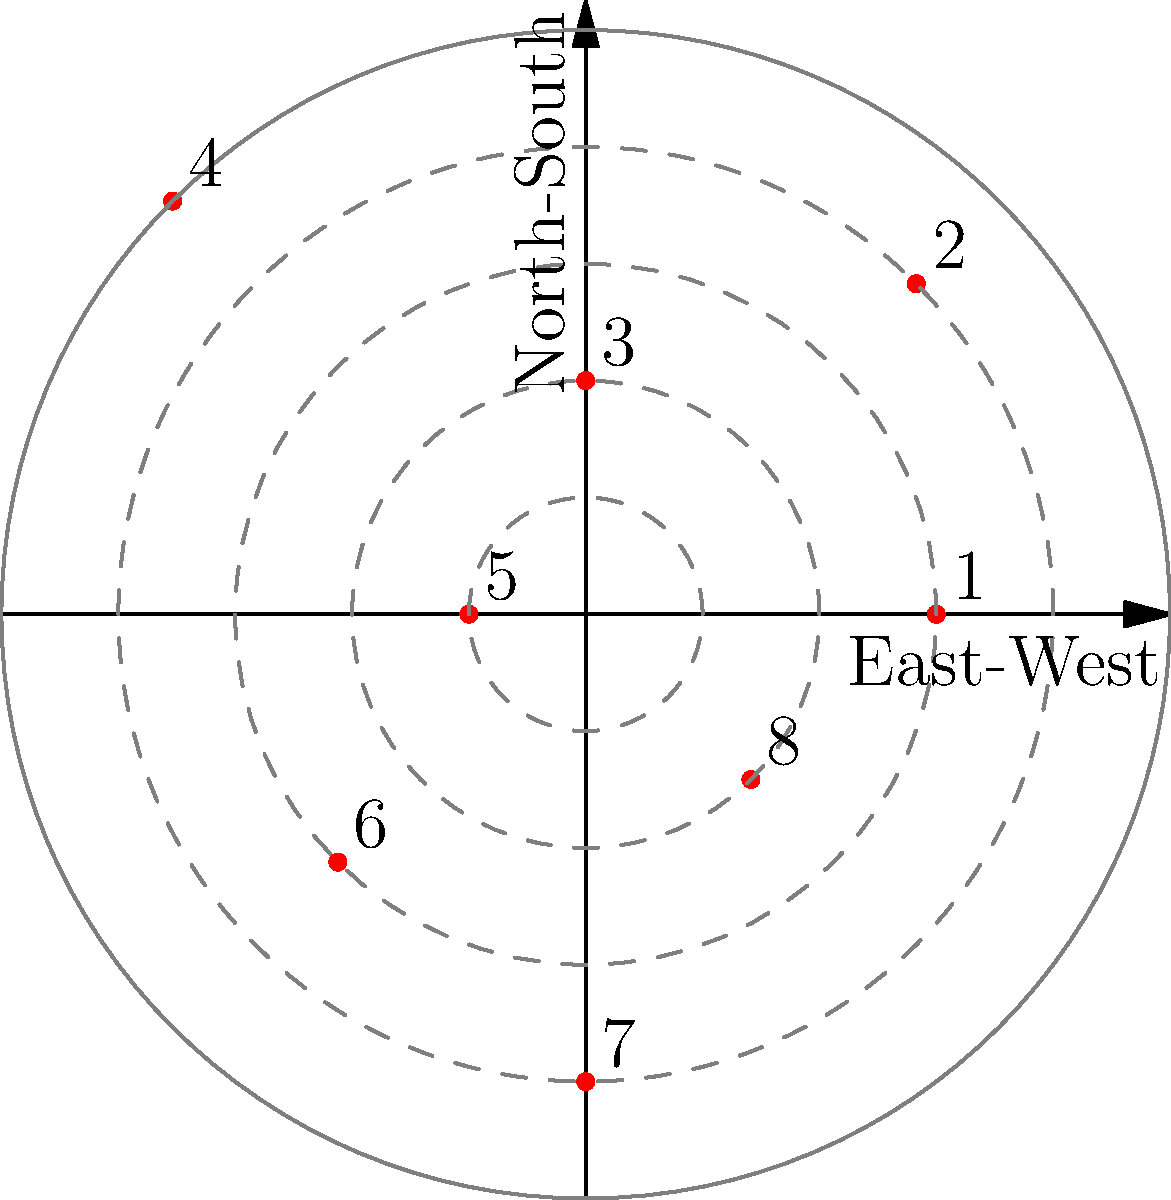In the polar coordinate representation of franchise locations, which quadrant contains the highest concentration of franchises, and how might this information be relevant for a business owner considering expansion? To answer this question, we need to analyze the polar coordinate representation of franchise locations:

1. The graph shows 8 franchise locations plotted on a polar coordinate system.
2. The quadrants are defined as follows:
   - Quadrant I: 0° to 90° (top-right)
   - Quadrant II: 90° to 180° (top-left)
   - Quadrant III: 180° to 270° (bottom-left)
   - Quadrant IV: 270° to 360° (bottom-right)

3. Counting the number of franchises in each quadrant:
   - Quadrant I: 3 franchises (points 1, 2, and 3)
   - Quadrant II: 2 franchises (points 4 and 5)
   - Quadrant III: 1 franchise (point 6)
   - Quadrant IV: 2 franchises (points 7 and 8)

4. Quadrant I has the highest concentration with 3 franchises.

5. Relevance for a business owner considering expansion:
   a) Market saturation: The high concentration in Quadrant I might indicate a saturated market, suggesting caution when expanding in this area.
   b) Proven success: Conversely, it could indicate a successful market, making it attractive for further expansion.
   c) Competitive analysis: Understanding the geographical spread helps in assessing competition and potential territories.
   d) Legal considerations: Different jurisdictions may have varying franchise laws and regulations, affecting expansion strategies.
   e) Supply chain optimization: Concentration of franchises may influence supply chain decisions and logistics planning.

This information is crucial for a business owner to make informed decisions about expansion strategies while considering legal and practical business aspects.
Answer: Quadrant I; informs market saturation, competition, and legal considerations for expansion. 